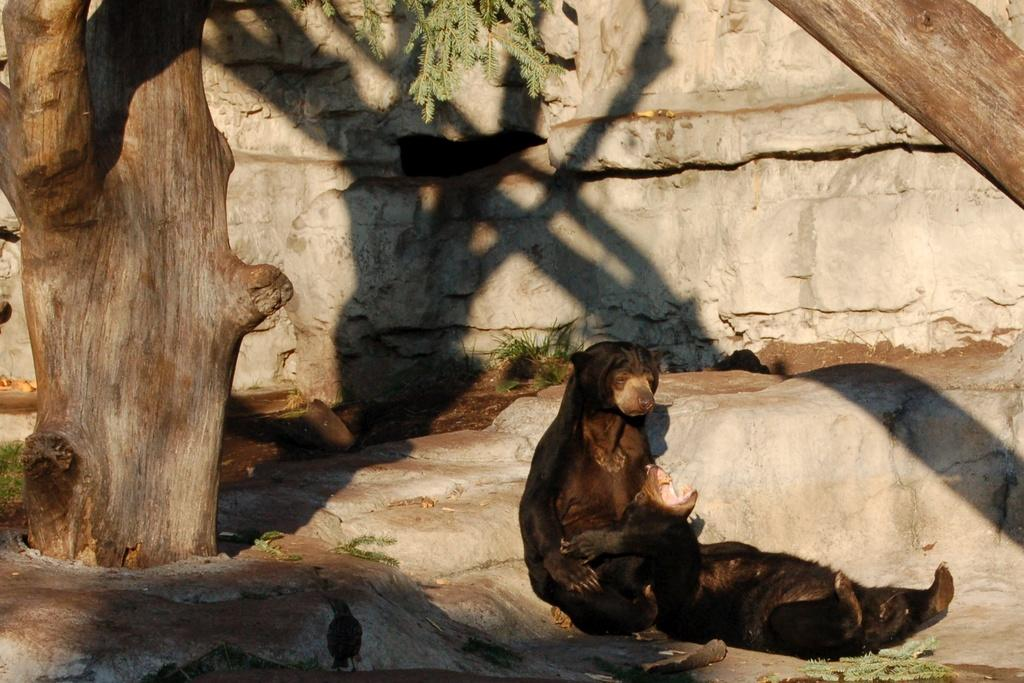How many animals are present in the image? There are two animals in the image. What type of animal can be seen in the image? There is a bird in the image. Where are the animals and bird located in the image? They are on a path in the image. What can be seen in the background of the image? There are tree trunks, leaves, and a wall in the background of the image. What part of the discussion is the bird participating in on the path? There is no discussion present in the image, as it features animals and a bird on a path with a background of tree trunks, leaves, and a wall. 